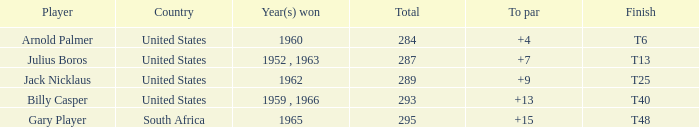Which player from the United States won in 1962? Jack Nicklaus. 